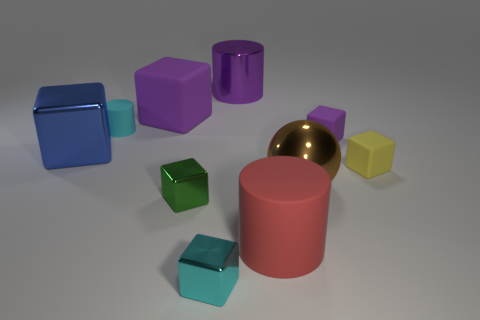There is a cylinder in front of the large object that is to the left of the big cube behind the small purple thing; what color is it?
Keep it short and to the point. Red. What material is the tiny cyan thing that is the same shape as the yellow thing?
Give a very brief answer. Metal. The metallic cylinder is what color?
Offer a very short reply. Purple. Is the large rubber cylinder the same color as the big metal block?
Offer a very short reply. No. What number of matte objects are large blue things or big cyan blocks?
Offer a very short reply. 0. Is there a tiny cylinder in front of the matte cylinder that is behind the rubber cylinder in front of the tiny yellow cube?
Make the answer very short. No. What size is the cyan block that is made of the same material as the tiny green block?
Offer a terse response. Small. There is a small green block; are there any large rubber things in front of it?
Provide a succinct answer. Yes. There is a cyan thing behind the yellow cube; is there a big purple cylinder that is to the left of it?
Your answer should be very brief. No. There is a cylinder that is in front of the green thing; is it the same size as the metallic object behind the blue metal object?
Ensure brevity in your answer.  Yes. 